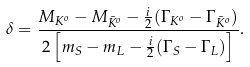<formula> <loc_0><loc_0><loc_500><loc_500>\delta = \frac { M _ { K ^ { o } } - M _ { \bar { K } ^ { o } } - \frac { i } { 2 } ( \Gamma _ { K ^ { o } } - \Gamma _ { \bar { K } ^ { o } } ) } { 2 \left [ m _ { S } - m _ { L } - \frac { i } { 2 } ( \Gamma _ { S } - \Gamma _ { L } ) \right ] } .</formula> 